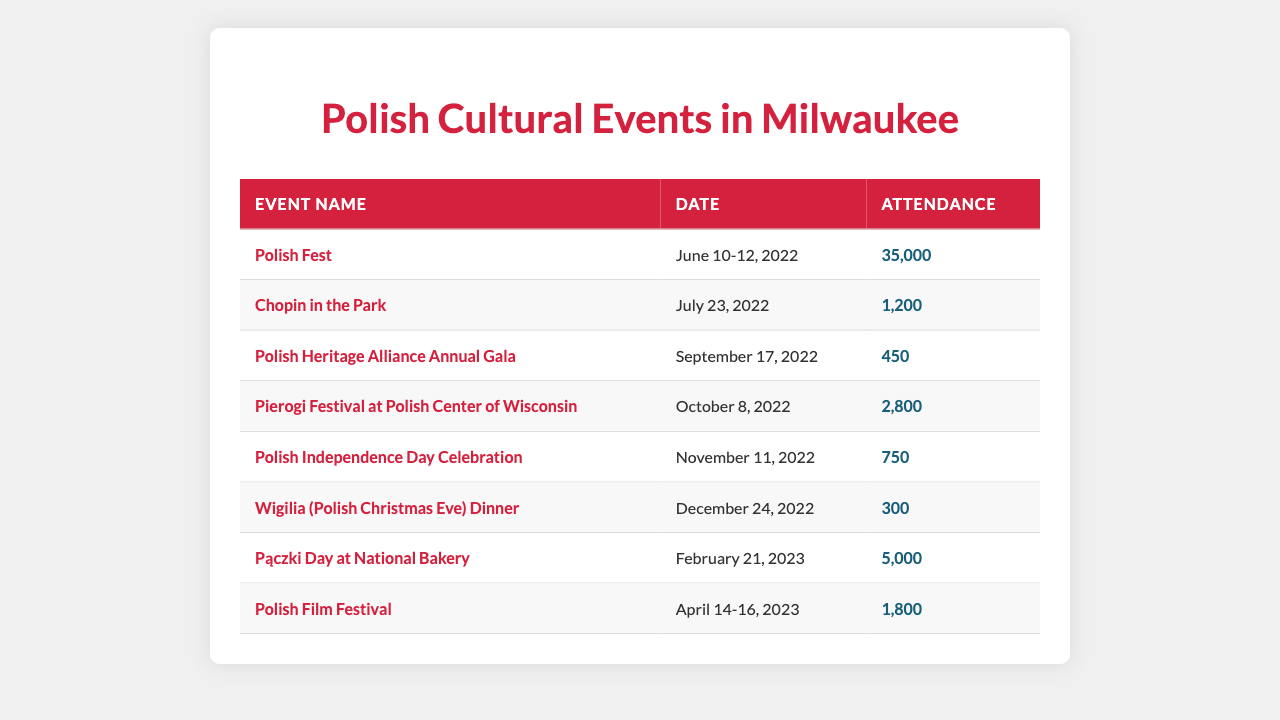What is the attendance for Polish Fest? The table shows that the attendance for Polish Fest, which took place from June 10 to June 12, 2022, is listed as 35,000.
Answer: 35,000 How many people attended the Polish Independence Day Celebration? The Polish Independence Day Celebration is listed in the table with an attendance figure of 750.
Answer: 750 What was the lowest attendance figure among these events? By looking at the attendance numbers in the table, Wigilia (Polish Christmas Eve) Dinner has the lowest attendance at 300.
Answer: 300 What is the total attendance for all events listed in the table? Summing all attendance figures gives (35,000 + 1,200 + 450 + 2,800 + 750 + 300 + 5,000 + 1,800) = 46,300.
Answer: 46,300 Did more than 15,000 people attend the Pierogi Festival at the Polish Center of Wisconsin? The table indicates that the attendance at the Pierogi Festival was 2,800, which is less than 15,000.
Answer: No Which event had a higher attendance: the Polish Film Festival or Chopin in the Park? The table shows that the Polish Film Festival had an attendance of 1,800, while Chopin in the Park had 1,200. Therefore, the Polish Film Festival had higher attendance.
Answer: Polish Film Festival What is the average attendance across all events? To calculate the average, add all attendance figures (total 46,300) and divide by the number of events (8). Thus, the average attendance is 46,300 / 8 = 5,787.5.
Answer: 5,787.5 How many events had an attendance of more than 1,000 people? By reviewing the attendance figures in the table, the events that had attendance over 1,000 are Polish Fest, Pączki Day, Pierogi Festival, and Polish Film Festival. This totals 4 events.
Answer: 4 Which event was the most popular based on attendance? The event with the highest attendance listed in the table is Polish Fest, with 35,000 attendees, making it the most popular event.
Answer: Polish Fest Was the attendance for the Wigilia Dinner over 400? The table shows the attendance at the Wigilia Dinner was 300, which is below 400.
Answer: No 